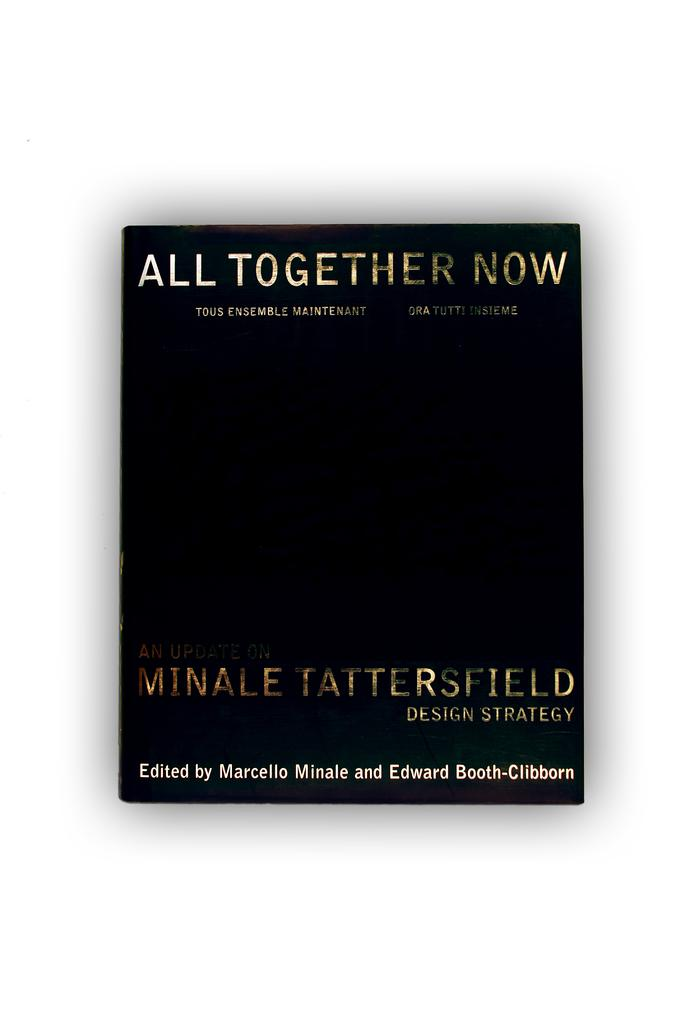<image>
Present a compact description of the photo's key features. A book titled All together now edited by two people. 